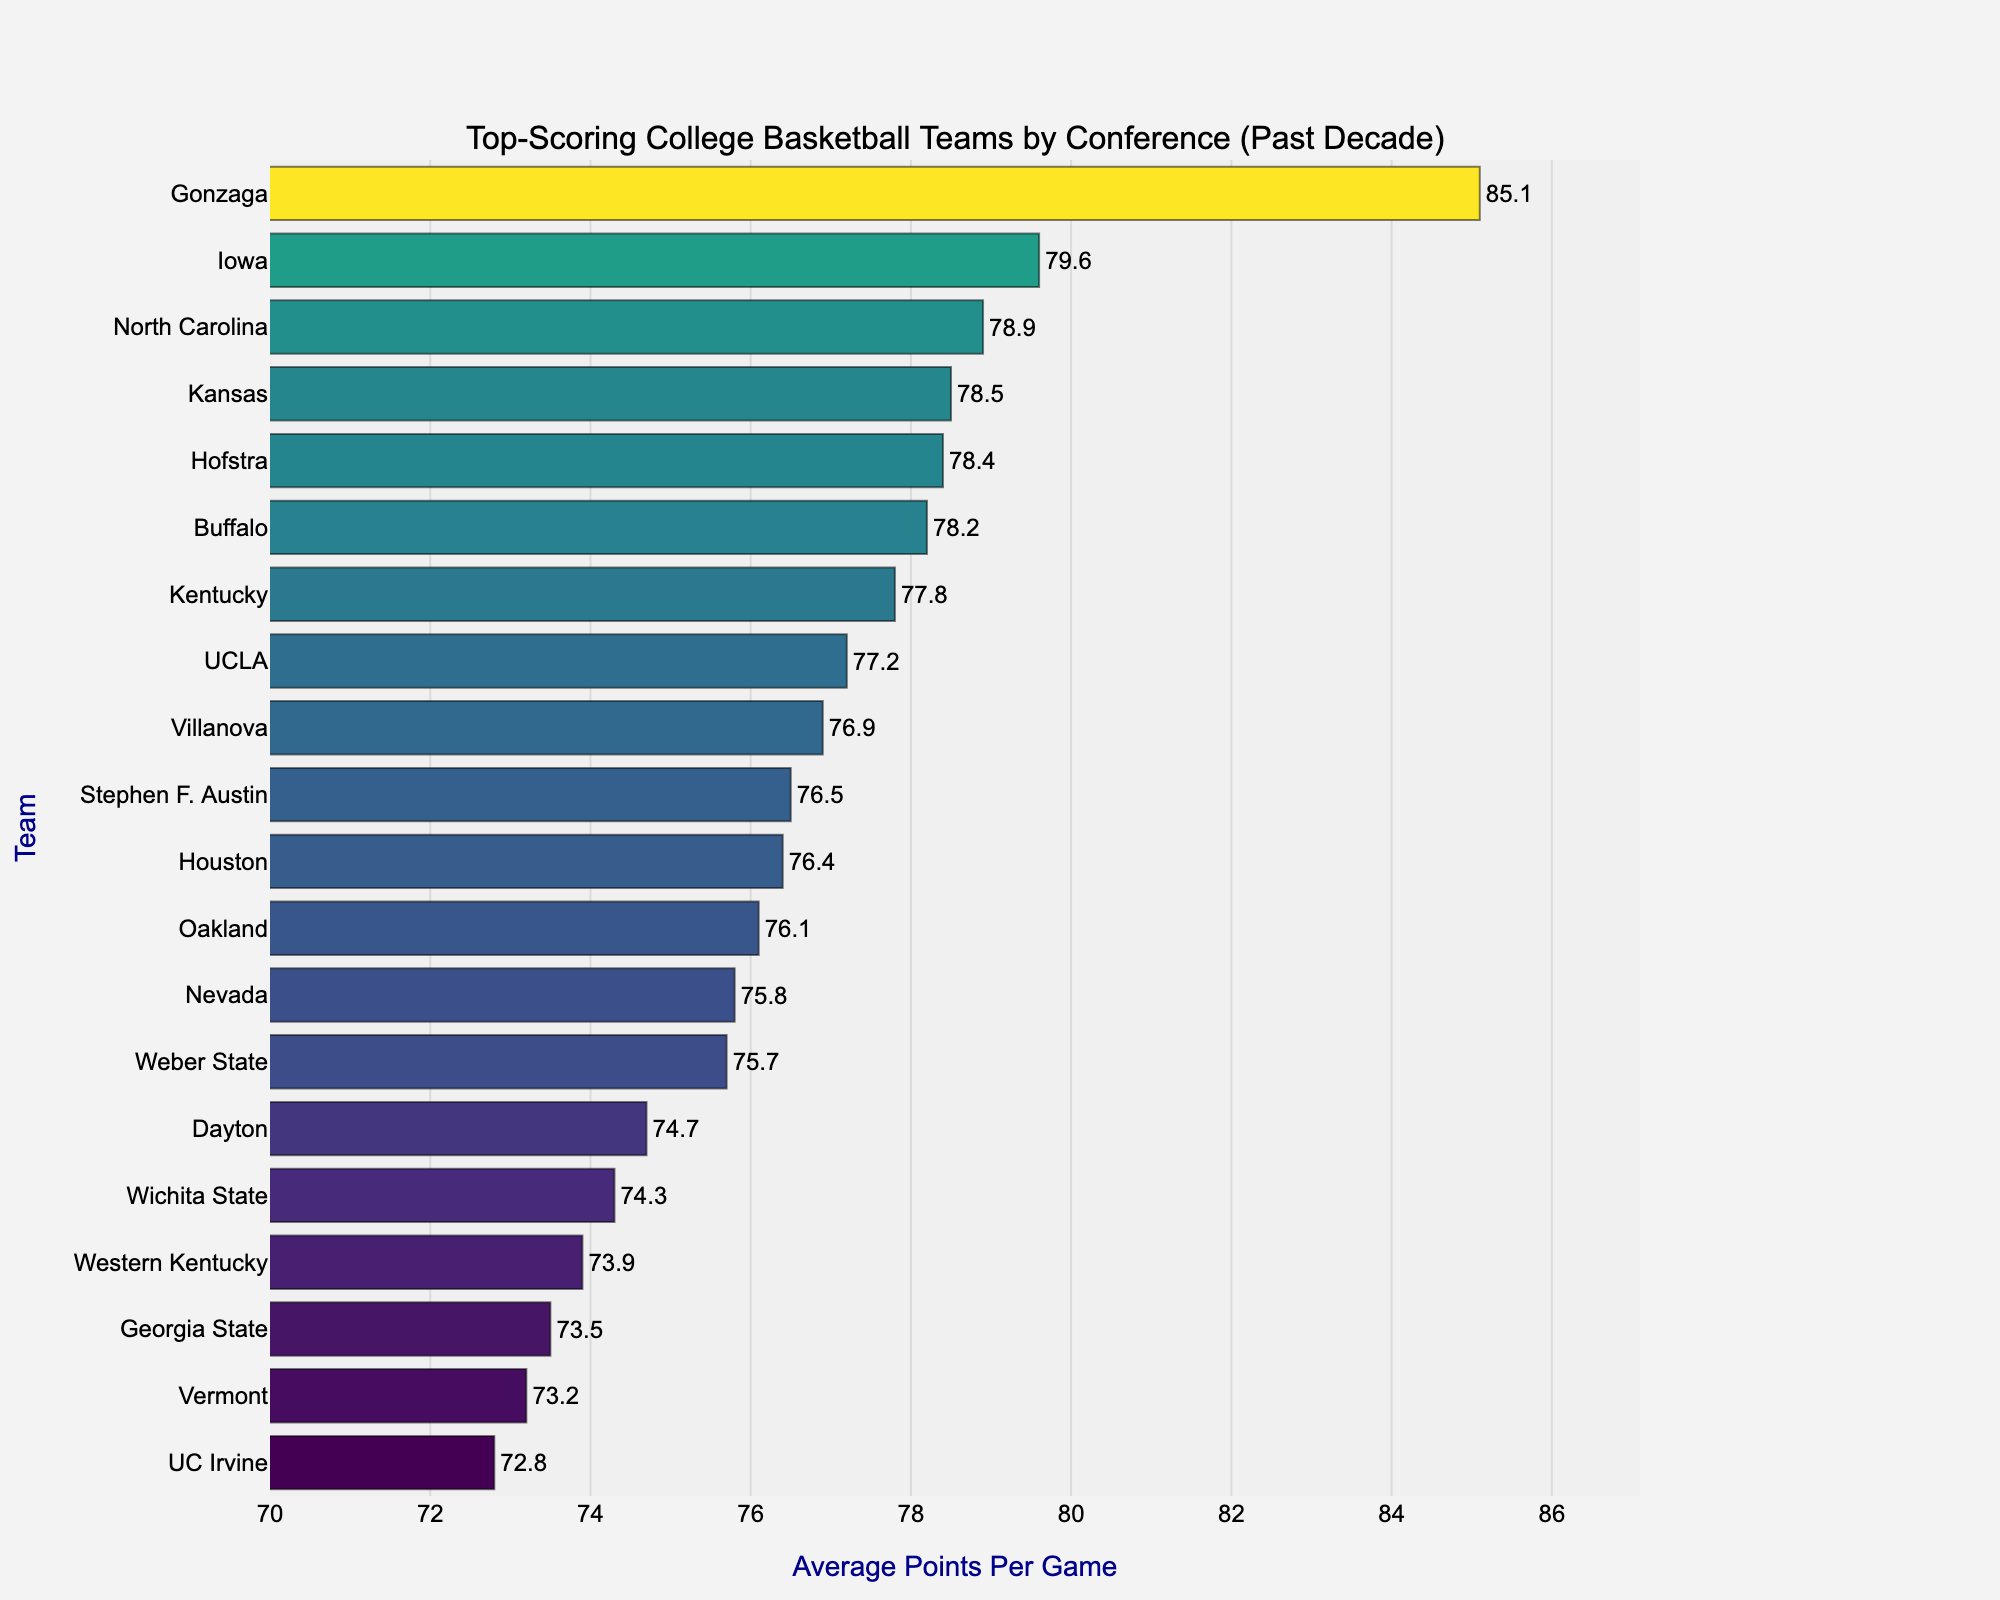What's the highest average points per game among the teams? Gonzaga has the highest average point per game, represented by the longest bar on the chart. The exact value is displayed at the end of the bar.
Answer: Gonzaga with 85.1 points Which team has a higher average points per game: Iowa or North Carolina? By comparing the lengths of the bars for Iowa and North Carolina, and looking at the values displayed, Iowa has 79.6 points while North Carolina has 78.9 points.
Answer: Iowa What is the total average points per game of Gonzaga and Dayton? The average points per game for Gonzaga is 85.1 and for Dayton is 74.7. Adding these gives 85.1 + 74.7.
Answer: 159.8 Which team in the Big Ten conference has the highest average points per game? From the given dataset, Iowa is part of the Big Ten conference and has an average of 79.6 points per game, which is the highest within Big Ten.
Answer: Iowa What's the difference in average points per game between the team with the highest value and the team with the lowest value (excluding Big West)? Gonzaga has the highest with 85.1 points and UC Irvine in the Big West has 72.8. The difference is 85.1 - 72.8.
Answer: 12.3 points What is the average of the top three highest-scoring teams? The top three teams based on bar length are Gonzaga (85.1), Iowa (79.6), and North Carolina (78.9). The average is calculated by (85.1 + 79.6 + 78.9) / 3.
Answer: 81.2 How does the average point per game for Villanova compare to that of Kentucky? Villanova has an average of 76.9 points per game and Kentucky has 77.8 points per game. Thus, Kentucky has a higher average.
Answer: Kentucky What is the sum of average points per game for Houston, UCLA, and Kansas? Houston has 76.4 points, UCLA has 77.2 points, and Kansas has 78.5 points. Adding these gives 76.4 + 77.2 + 78.5.
Answer: 232.1 Which conference does Vermont belong to, and what is their average points per game? Vermont belongs to the America East conference and their average points per game is shown as 73.2 on the chart.
Answer: America East, 73.2 points How many teams have an average points per game above 78? By looking at the bar lengths and values, the teams that have an average above 78 points are Gonzaga, Iowa, North Carolina, Kansas, and Buffalo. This totals to 5 teams.
Answer: 5 teams 